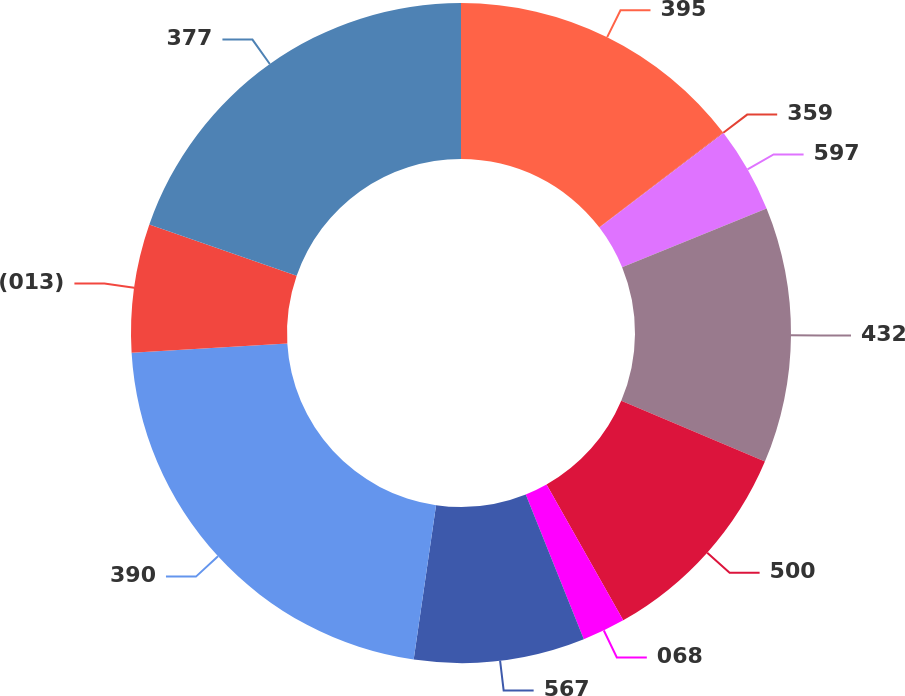<chart> <loc_0><loc_0><loc_500><loc_500><pie_chart><fcel>395<fcel>359<fcel>597<fcel>432<fcel>500<fcel>068<fcel>567<fcel>390<fcel>(013)<fcel>377<nl><fcel>14.61%<fcel>0.03%<fcel>4.2%<fcel>12.53%<fcel>10.45%<fcel>2.11%<fcel>8.36%<fcel>21.76%<fcel>6.28%<fcel>19.67%<nl></chart> 